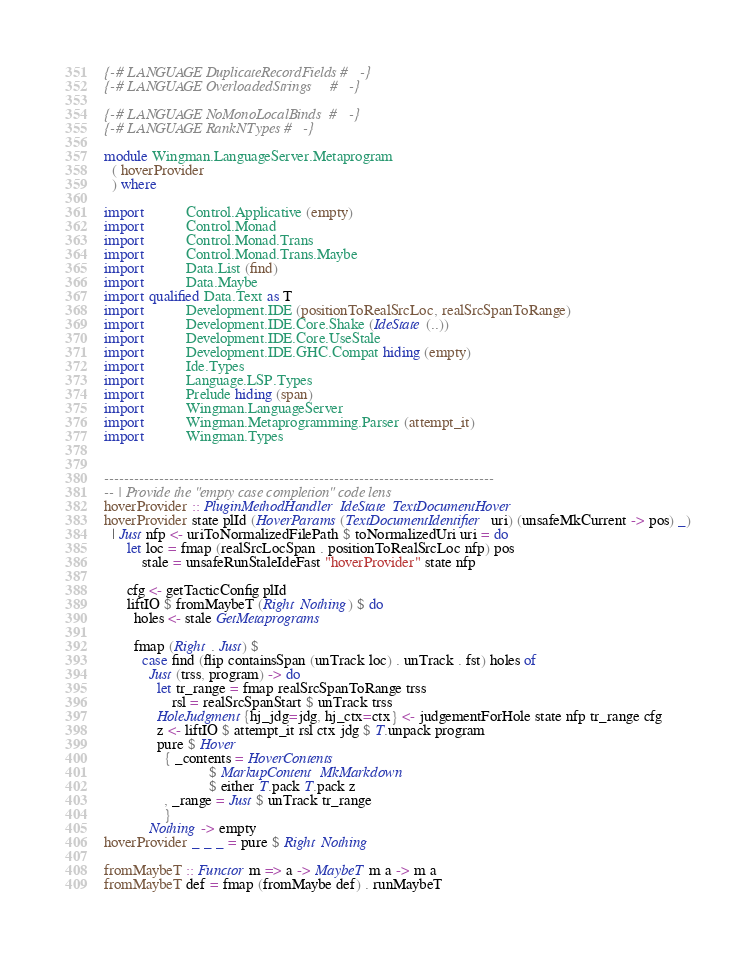<code> <loc_0><loc_0><loc_500><loc_500><_Haskell_>{-# LANGUAGE DuplicateRecordFields #-}
{-# LANGUAGE OverloadedStrings     #-}

{-# LANGUAGE NoMonoLocalBinds  #-}
{-# LANGUAGE RankNTypes #-}

module Wingman.LanguageServer.Metaprogram
  ( hoverProvider
  ) where

import           Control.Applicative (empty)
import           Control.Monad
import           Control.Monad.Trans
import           Control.Monad.Trans.Maybe
import           Data.List (find)
import           Data.Maybe
import qualified Data.Text as T
import           Development.IDE (positionToRealSrcLoc, realSrcSpanToRange)
import           Development.IDE.Core.Shake (IdeState (..))
import           Development.IDE.Core.UseStale
import           Development.IDE.GHC.Compat hiding (empty)
import           Ide.Types
import           Language.LSP.Types
import           Prelude hiding (span)
import           Wingman.LanguageServer
import           Wingman.Metaprogramming.Parser (attempt_it)
import           Wingman.Types


------------------------------------------------------------------------------
-- | Provide the "empty case completion" code lens
hoverProvider :: PluginMethodHandler IdeState TextDocumentHover
hoverProvider state plId (HoverParams (TextDocumentIdentifier uri) (unsafeMkCurrent -> pos) _)
  | Just nfp <- uriToNormalizedFilePath $ toNormalizedUri uri = do
      let loc = fmap (realSrcLocSpan . positionToRealSrcLoc nfp) pos
          stale = unsafeRunStaleIdeFast "hoverProvider" state nfp

      cfg <- getTacticConfig plId
      liftIO $ fromMaybeT (Right Nothing) $ do
        holes <- stale GetMetaprograms

        fmap (Right . Just) $
          case find (flip containsSpan (unTrack loc) . unTrack . fst) holes of
            Just (trss, program) -> do
              let tr_range = fmap realSrcSpanToRange trss
                  rsl = realSrcSpanStart $ unTrack trss
              HoleJudgment{hj_jdg=jdg, hj_ctx=ctx} <- judgementForHole state nfp tr_range cfg
              z <- liftIO $ attempt_it rsl ctx jdg $ T.unpack program
              pure $ Hover
                { _contents = HoverContents
                            $ MarkupContent MkMarkdown
                            $ either T.pack T.pack z
                , _range = Just $ unTrack tr_range
                }
            Nothing -> empty
hoverProvider _ _ _ = pure $ Right Nothing

fromMaybeT :: Functor m => a -> MaybeT m a -> m a
fromMaybeT def = fmap (fromMaybe def) . runMaybeT
</code> 